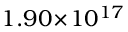<formula> <loc_0><loc_0><loc_500><loc_500>1 . 9 0 \, \times \, 1 0 ^ { 1 7 }</formula> 